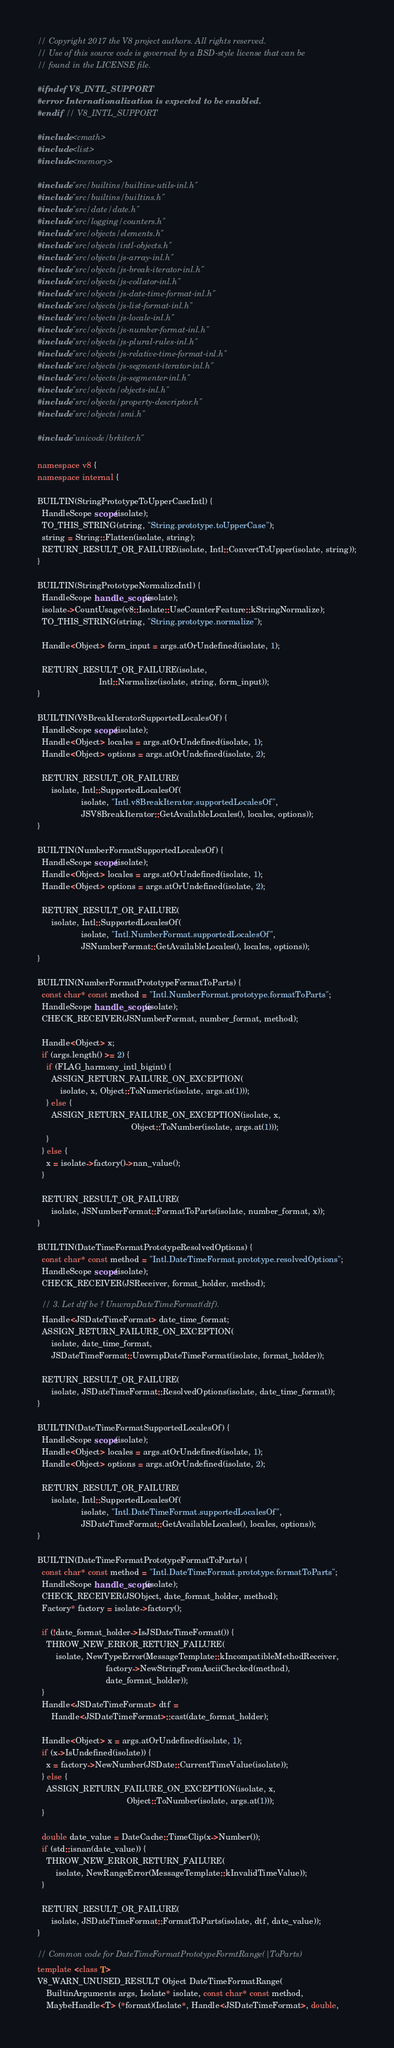<code> <loc_0><loc_0><loc_500><loc_500><_C++_>// Copyright 2017 the V8 project authors. All rights reserved.
// Use of this source code is governed by a BSD-style license that can be
// found in the LICENSE file.

#ifndef V8_INTL_SUPPORT
#error Internationalization is expected to be enabled.
#endif  // V8_INTL_SUPPORT

#include <cmath>
#include <list>
#include <memory>

#include "src/builtins/builtins-utils-inl.h"
#include "src/builtins/builtins.h"
#include "src/date/date.h"
#include "src/logging/counters.h"
#include "src/objects/elements.h"
#include "src/objects/intl-objects.h"
#include "src/objects/js-array-inl.h"
#include "src/objects/js-break-iterator-inl.h"
#include "src/objects/js-collator-inl.h"
#include "src/objects/js-date-time-format-inl.h"
#include "src/objects/js-list-format-inl.h"
#include "src/objects/js-locale-inl.h"
#include "src/objects/js-number-format-inl.h"
#include "src/objects/js-plural-rules-inl.h"
#include "src/objects/js-relative-time-format-inl.h"
#include "src/objects/js-segment-iterator-inl.h"
#include "src/objects/js-segmenter-inl.h"
#include "src/objects/objects-inl.h"
#include "src/objects/property-descriptor.h"
#include "src/objects/smi.h"

#include "unicode/brkiter.h"

namespace v8 {
namespace internal {

BUILTIN(StringPrototypeToUpperCaseIntl) {
  HandleScope scope(isolate);
  TO_THIS_STRING(string, "String.prototype.toUpperCase");
  string = String::Flatten(isolate, string);
  RETURN_RESULT_OR_FAILURE(isolate, Intl::ConvertToUpper(isolate, string));
}

BUILTIN(StringPrototypeNormalizeIntl) {
  HandleScope handle_scope(isolate);
  isolate->CountUsage(v8::Isolate::UseCounterFeature::kStringNormalize);
  TO_THIS_STRING(string, "String.prototype.normalize");

  Handle<Object> form_input = args.atOrUndefined(isolate, 1);

  RETURN_RESULT_OR_FAILURE(isolate,
                           Intl::Normalize(isolate, string, form_input));
}

BUILTIN(V8BreakIteratorSupportedLocalesOf) {
  HandleScope scope(isolate);
  Handle<Object> locales = args.atOrUndefined(isolate, 1);
  Handle<Object> options = args.atOrUndefined(isolate, 2);

  RETURN_RESULT_OR_FAILURE(
      isolate, Intl::SupportedLocalesOf(
                   isolate, "Intl.v8BreakIterator.supportedLocalesOf",
                   JSV8BreakIterator::GetAvailableLocales(), locales, options));
}

BUILTIN(NumberFormatSupportedLocalesOf) {
  HandleScope scope(isolate);
  Handle<Object> locales = args.atOrUndefined(isolate, 1);
  Handle<Object> options = args.atOrUndefined(isolate, 2);

  RETURN_RESULT_OR_FAILURE(
      isolate, Intl::SupportedLocalesOf(
                   isolate, "Intl.NumberFormat.supportedLocalesOf",
                   JSNumberFormat::GetAvailableLocales(), locales, options));
}

BUILTIN(NumberFormatPrototypeFormatToParts) {
  const char* const method = "Intl.NumberFormat.prototype.formatToParts";
  HandleScope handle_scope(isolate);
  CHECK_RECEIVER(JSNumberFormat, number_format, method);

  Handle<Object> x;
  if (args.length() >= 2) {
    if (FLAG_harmony_intl_bigint) {
      ASSIGN_RETURN_FAILURE_ON_EXCEPTION(
          isolate, x, Object::ToNumeric(isolate, args.at(1)));
    } else {
      ASSIGN_RETURN_FAILURE_ON_EXCEPTION(isolate, x,
                                         Object::ToNumber(isolate, args.at(1)));
    }
  } else {
    x = isolate->factory()->nan_value();
  }

  RETURN_RESULT_OR_FAILURE(
      isolate, JSNumberFormat::FormatToParts(isolate, number_format, x));
}

BUILTIN(DateTimeFormatPrototypeResolvedOptions) {
  const char* const method = "Intl.DateTimeFormat.prototype.resolvedOptions";
  HandleScope scope(isolate);
  CHECK_RECEIVER(JSReceiver, format_holder, method);

  // 3. Let dtf be ? UnwrapDateTimeFormat(dtf).
  Handle<JSDateTimeFormat> date_time_format;
  ASSIGN_RETURN_FAILURE_ON_EXCEPTION(
      isolate, date_time_format,
      JSDateTimeFormat::UnwrapDateTimeFormat(isolate, format_holder));

  RETURN_RESULT_OR_FAILURE(
      isolate, JSDateTimeFormat::ResolvedOptions(isolate, date_time_format));
}

BUILTIN(DateTimeFormatSupportedLocalesOf) {
  HandleScope scope(isolate);
  Handle<Object> locales = args.atOrUndefined(isolate, 1);
  Handle<Object> options = args.atOrUndefined(isolate, 2);

  RETURN_RESULT_OR_FAILURE(
      isolate, Intl::SupportedLocalesOf(
                   isolate, "Intl.DateTimeFormat.supportedLocalesOf",
                   JSDateTimeFormat::GetAvailableLocales(), locales, options));
}

BUILTIN(DateTimeFormatPrototypeFormatToParts) {
  const char* const method = "Intl.DateTimeFormat.prototype.formatToParts";
  HandleScope handle_scope(isolate);
  CHECK_RECEIVER(JSObject, date_format_holder, method);
  Factory* factory = isolate->factory();

  if (!date_format_holder->IsJSDateTimeFormat()) {
    THROW_NEW_ERROR_RETURN_FAILURE(
        isolate, NewTypeError(MessageTemplate::kIncompatibleMethodReceiver,
                              factory->NewStringFromAsciiChecked(method),
                              date_format_holder));
  }
  Handle<JSDateTimeFormat> dtf =
      Handle<JSDateTimeFormat>::cast(date_format_holder);

  Handle<Object> x = args.atOrUndefined(isolate, 1);
  if (x->IsUndefined(isolate)) {
    x = factory->NewNumber(JSDate::CurrentTimeValue(isolate));
  } else {
    ASSIGN_RETURN_FAILURE_ON_EXCEPTION(isolate, x,
                                       Object::ToNumber(isolate, args.at(1)));
  }

  double date_value = DateCache::TimeClip(x->Number());
  if (std::isnan(date_value)) {
    THROW_NEW_ERROR_RETURN_FAILURE(
        isolate, NewRangeError(MessageTemplate::kInvalidTimeValue));
  }

  RETURN_RESULT_OR_FAILURE(
      isolate, JSDateTimeFormat::FormatToParts(isolate, dtf, date_value));
}

// Common code for DateTimeFormatPrototypeFormtRange(|ToParts)
template <class T>
V8_WARN_UNUSED_RESULT Object DateTimeFormatRange(
    BuiltinArguments args, Isolate* isolate, const char* const method,
    MaybeHandle<T> (*format)(Isolate*, Handle<JSDateTimeFormat>, double,</code> 